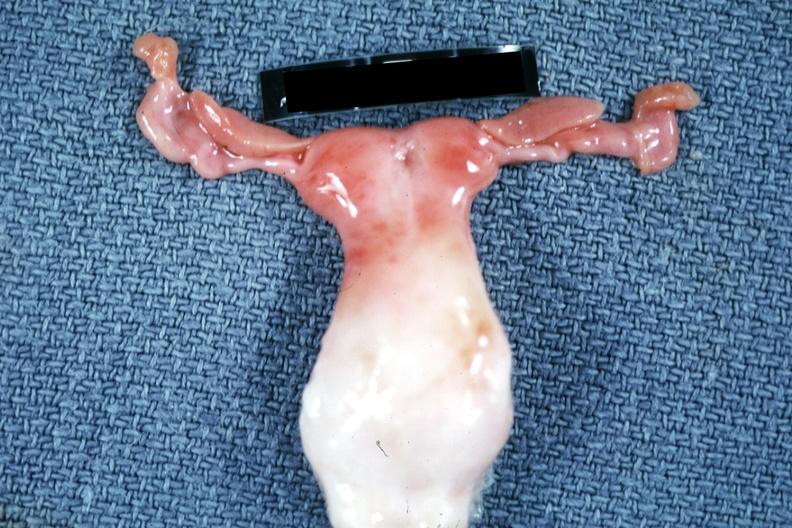s female reproductive present?
Answer the question using a single word or phrase. Yes 